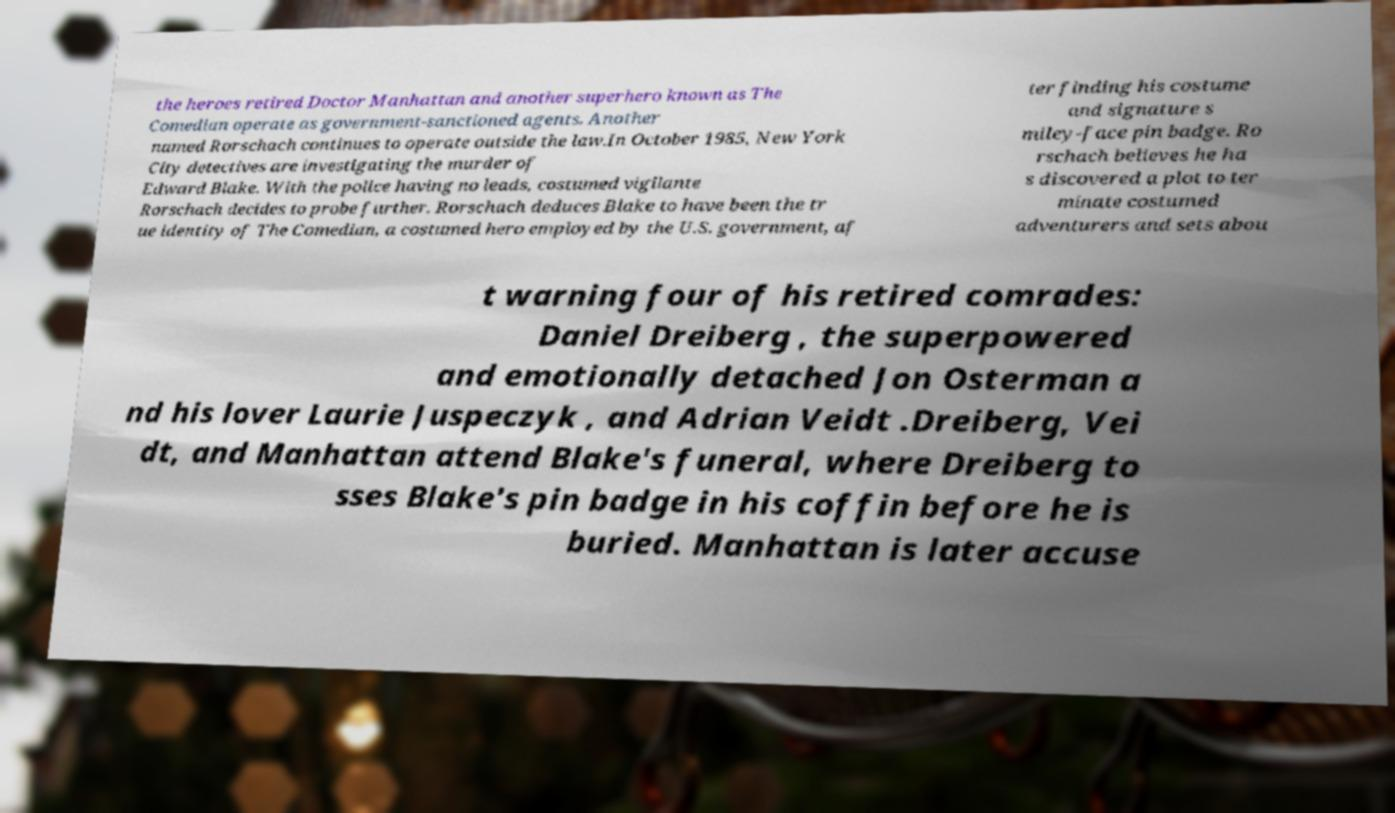Can you read and provide the text displayed in the image?This photo seems to have some interesting text. Can you extract and type it out for me? the heroes retired Doctor Manhattan and another superhero known as The Comedian operate as government-sanctioned agents. Another named Rorschach continues to operate outside the law.In October 1985, New York City detectives are investigating the murder of Edward Blake. With the police having no leads, costumed vigilante Rorschach decides to probe further. Rorschach deduces Blake to have been the tr ue identity of The Comedian, a costumed hero employed by the U.S. government, af ter finding his costume and signature s miley-face pin badge. Ro rschach believes he ha s discovered a plot to ter minate costumed adventurers and sets abou t warning four of his retired comrades: Daniel Dreiberg , the superpowered and emotionally detached Jon Osterman a nd his lover Laurie Juspeczyk , and Adrian Veidt .Dreiberg, Vei dt, and Manhattan attend Blake's funeral, where Dreiberg to sses Blake's pin badge in his coffin before he is buried. Manhattan is later accuse 